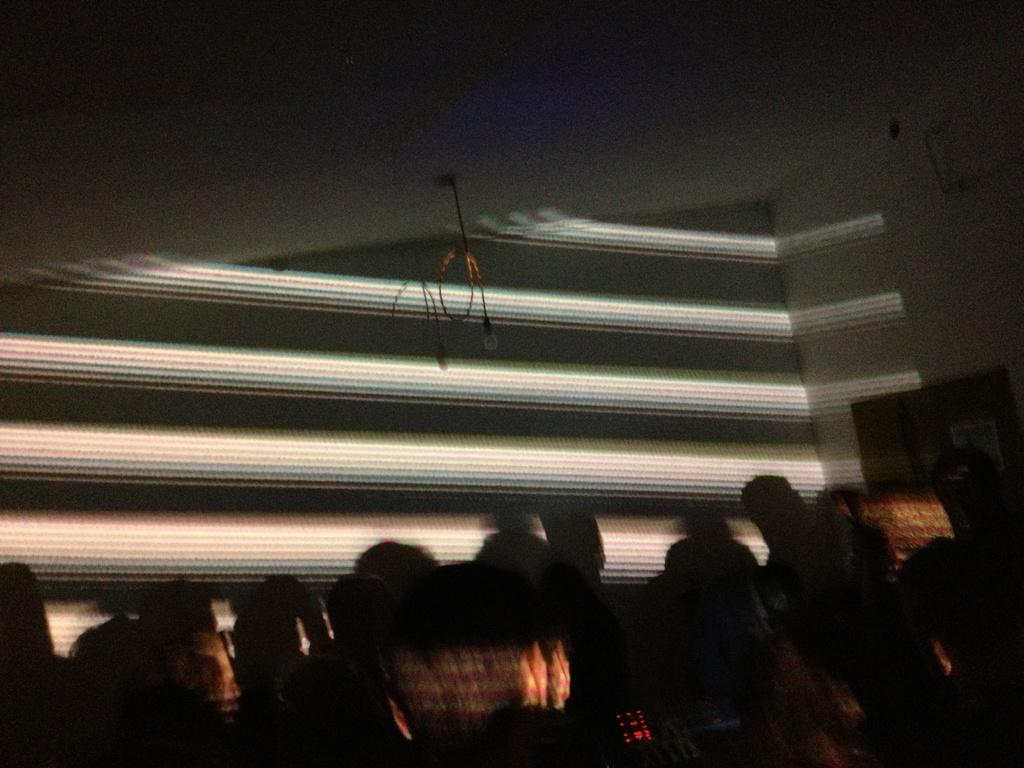How many people are in the image? There are people in the image, but the exact number is not specified. What are the people doing in the image? The people are standing in the image. Can you describe the lighting in the image? The room is dark in the image. What type of treatment is being administered to the person with the disease in the image? There is no mention of a person with a disease or any treatment being administered in the image. 